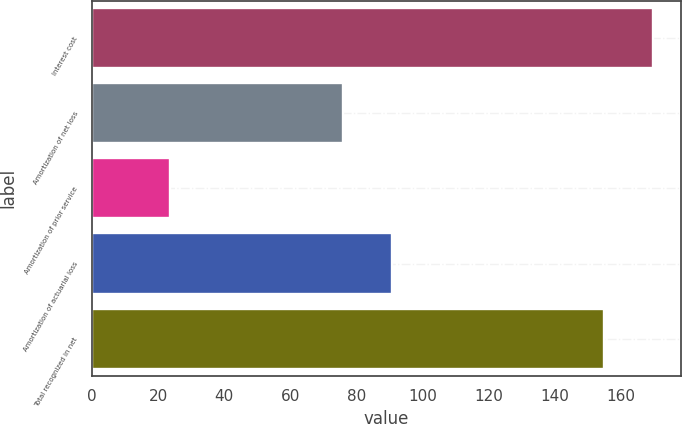<chart> <loc_0><loc_0><loc_500><loc_500><bar_chart><fcel>Interest cost<fcel>Amortization of net loss<fcel>Amortization of prior service<fcel>Amortization of actuarial loss<fcel>Total recognized in net<nl><fcel>169.7<fcel>76<fcel>23.7<fcel>90.7<fcel>155<nl></chart> 